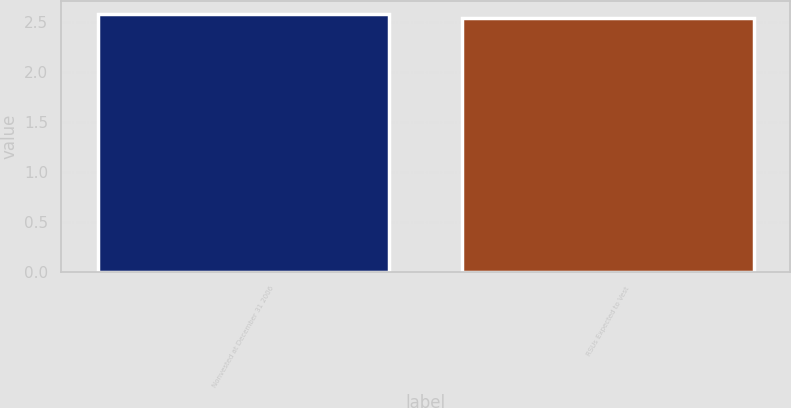Convert chart. <chart><loc_0><loc_0><loc_500><loc_500><bar_chart><fcel>Nonvested at December 31 2006<fcel>RSUs Expected to Vest<nl><fcel>2.58<fcel>2.54<nl></chart> 